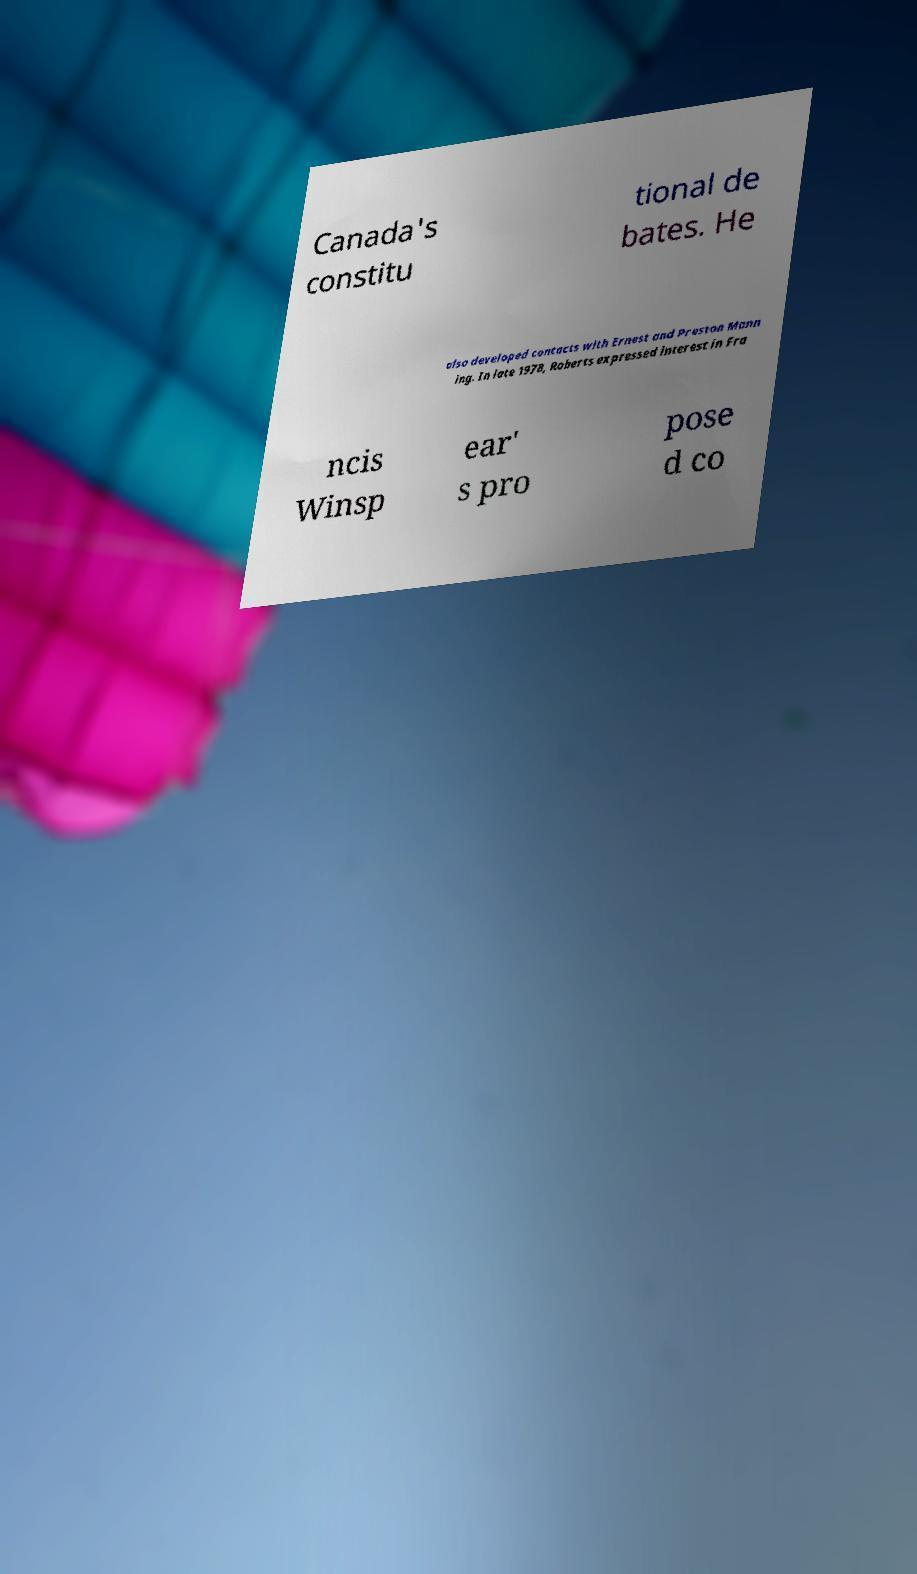Please identify and transcribe the text found in this image. Canada's constitu tional de bates. He also developed contacts with Ernest and Preston Mann ing. In late 1978, Roberts expressed interest in Fra ncis Winsp ear' s pro pose d co 